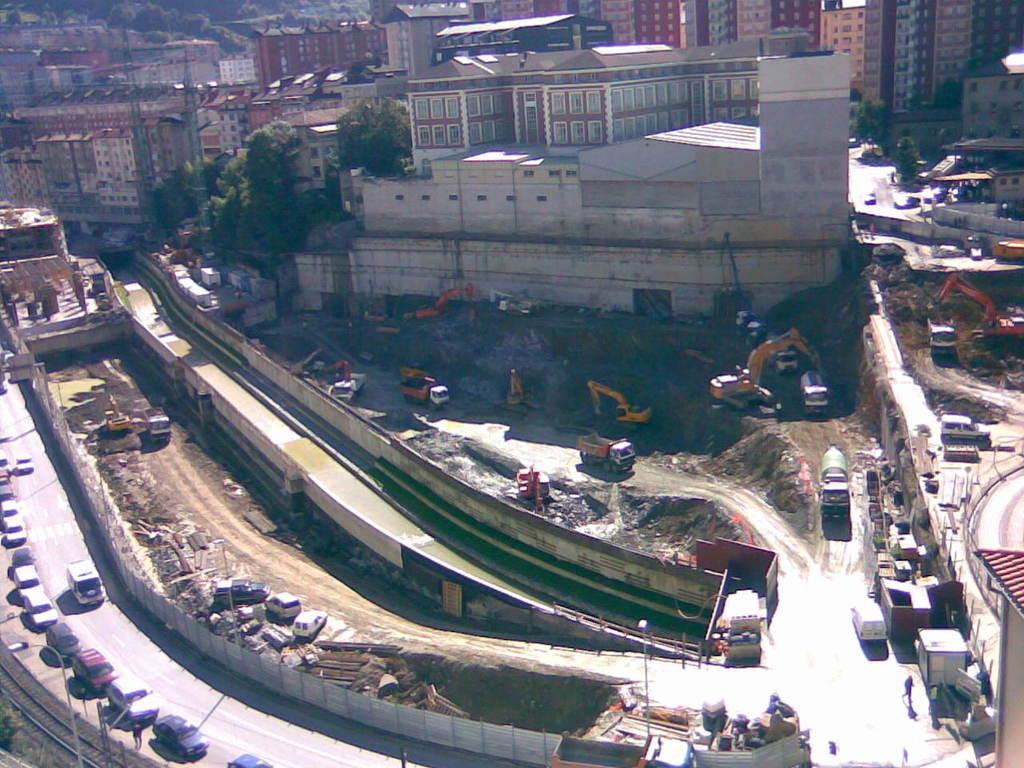How would you summarize this image in a sentence or two? This is a picture of a city , where there are vehicles on the road , buildings, trees, lights, poles. 